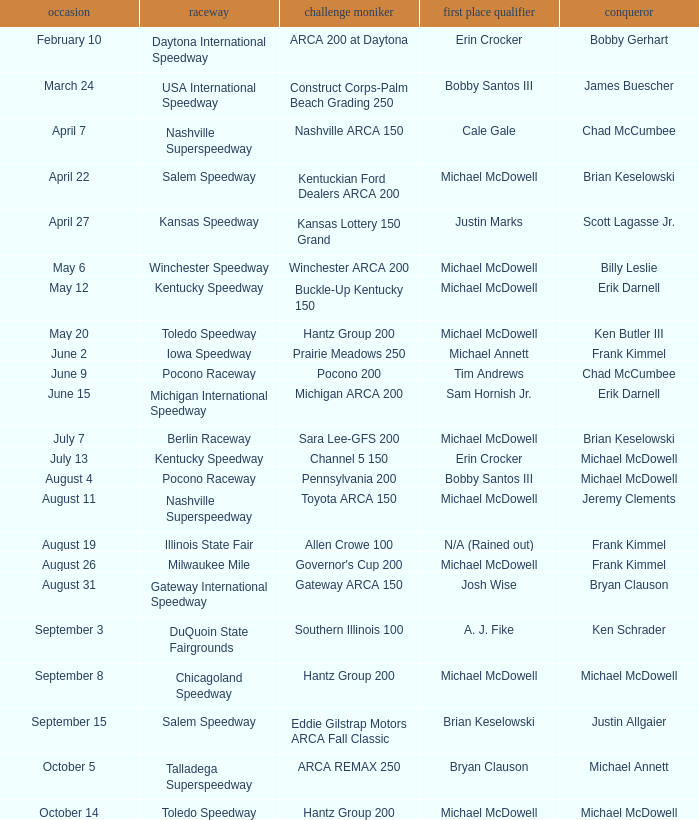Tell me the track for scott lagasse jr. Kansas Speedway. 